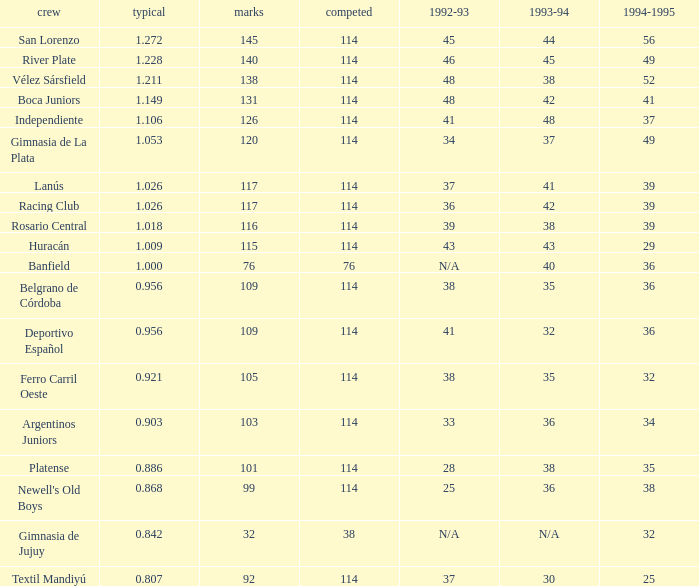Name the total number of 1992-93 for 115 points 1.0. 